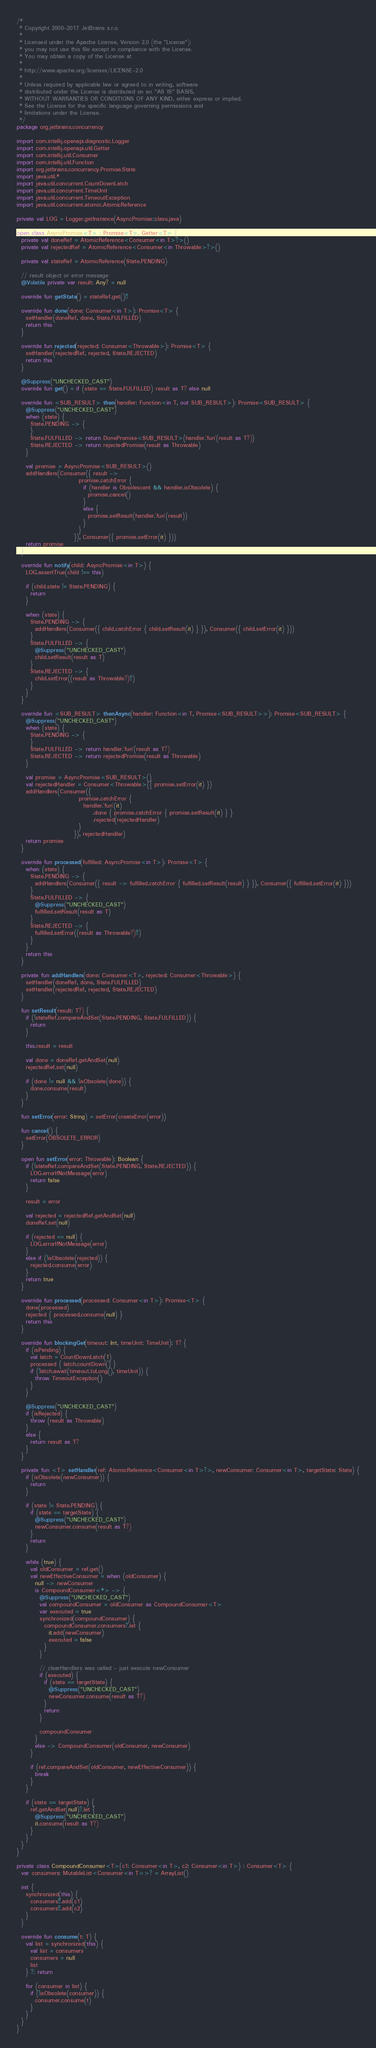Convert code to text. <code><loc_0><loc_0><loc_500><loc_500><_Kotlin_>/*
 * Copyright 2000-2017 JetBrains s.r.o.
 *
 * Licensed under the Apache License, Version 2.0 (the "License");
 * you may not use this file except in compliance with the License.
 * You may obtain a copy of the License at
 *
 * http://www.apache.org/licenses/LICENSE-2.0
 *
 * Unless required by applicable law or agreed to in writing, software
 * distributed under the License is distributed on an "AS IS" BASIS,
 * WITHOUT WARRANTIES OR CONDITIONS OF ANY KIND, either express or implied.
 * See the License for the specific language governing permissions and
 * limitations under the License.
 */
package org.jetbrains.concurrency

import com.intellij.openapi.diagnostic.Logger
import com.intellij.openapi.util.Getter
import com.intellij.util.Consumer
import com.intellij.util.Function
import org.jetbrains.concurrency.Promise.State
import java.util.*
import java.util.concurrent.CountDownLatch
import java.util.concurrent.TimeUnit
import java.util.concurrent.TimeoutException
import java.util.concurrent.atomic.AtomicReference

private val LOG = Logger.getInstance(AsyncPromise::class.java)

open class AsyncPromise<T> : Promise<T>, Getter<T> {
  private val doneRef = AtomicReference<Consumer<in T>?>()
  private val rejectedRef = AtomicReference<Consumer<in Throwable>?>()

  private val stateRef = AtomicReference(State.PENDING)

  // result object or error message
  @Volatile private var result: Any? = null

  override fun getState() = stateRef.get()!!

  override fun done(done: Consumer<in T>): Promise<T> {
    setHandler(doneRef, done, State.FULFILLED)
    return this
  }

  override fun rejected(rejected: Consumer<Throwable>): Promise<T> {
    setHandler(rejectedRef, rejected, State.REJECTED)
    return this
  }

  @Suppress("UNCHECKED_CAST")
  override fun get() = if (state == State.FULFILLED) result as T? else null

  override fun <SUB_RESULT> then(handler: Function<in T, out SUB_RESULT>): Promise<SUB_RESULT> {
    @Suppress("UNCHECKED_CAST")
    when (state) {
      State.PENDING -> {
      }
      State.FULFILLED -> return DonePromise<SUB_RESULT>(handler.`fun`(result as T?))
      State.REJECTED -> return rejectedPromise(result as Throwable)
    }

    val promise = AsyncPromise<SUB_RESULT>()
    addHandlers(Consumer({ result ->
                           promise.catchError {
                             if (handler is Obsolescent && handler.isObsolete) {
                               promise.cancel()
                             }
                             else {
                               promise.setResult(handler.`fun`(result))
                             }
                           }
                         }), Consumer({ promise.setError(it) }))
    return promise
  }

  override fun notify(child: AsyncPromise<in T>) {
    LOG.assertTrue(child !== this)

    if (child.state != State.PENDING) {
      return
    }

    when (state) {
      State.PENDING -> {
        addHandlers(Consumer({ child.catchError { child.setResult(it) } }), Consumer({ child.setError(it) }))
      }
      State.FULFILLED -> {
        @Suppress("UNCHECKED_CAST")
        child.setResult(result as T)
      }
      State.REJECTED -> {
        child.setError((result as Throwable?)!!)
      }
    }
  }

  override fun <SUB_RESULT> thenAsync(handler: Function<in T, Promise<SUB_RESULT>>): Promise<SUB_RESULT> {
    @Suppress("UNCHECKED_CAST")
    when (state) {
      State.PENDING -> {
      }
      State.FULFILLED -> return handler.`fun`(result as T?)
      State.REJECTED -> return rejectedPromise(result as Throwable)
    }

    val promise = AsyncPromise<SUB_RESULT>()
    val rejectedHandler = Consumer<Throwable>({ promise.setError(it) })
    addHandlers(Consumer({
                           promise.catchError {
                             handler.`fun`(it)
                                 .done { promise.catchError { promise.setResult(it) } }
                                 .rejected(rejectedHandler)
                           }
                         }), rejectedHandler)
    return promise
  }

  override fun processed(fulfilled: AsyncPromise<in T>): Promise<T> {
    when (state) {
      State.PENDING -> {
        addHandlers(Consumer({ result -> fulfilled.catchError { fulfilled.setResult(result) } }), Consumer({ fulfilled.setError(it) }))
      }
      State.FULFILLED -> {
        @Suppress("UNCHECKED_CAST")
        fulfilled.setResult(result as T)
      }
      State.REJECTED -> {
        fulfilled.setError((result as Throwable?)!!)
      }
    }
    return this
  }

  private fun addHandlers(done: Consumer<T>, rejected: Consumer<Throwable>) {
    setHandler(doneRef, done, State.FULFILLED)
    setHandler(rejectedRef, rejected, State.REJECTED)
  }

  fun setResult(result: T?) {
    if (!stateRef.compareAndSet(State.PENDING, State.FULFILLED)) {
      return
    }

    this.result = result

    val done = doneRef.getAndSet(null)
    rejectedRef.set(null)

    if (done != null && !isObsolete(done)) {
      done.consume(result)
    }
  }

  fun setError(error: String) = setError(createError(error))

  fun cancel() {
    setError(OBSOLETE_ERROR)
  }

  open fun setError(error: Throwable): Boolean {
    if (!stateRef.compareAndSet(State.PENDING, State.REJECTED)) {
      LOG.errorIfNotMessage(error)
      return false
    }

    result = error

    val rejected = rejectedRef.getAndSet(null)
    doneRef.set(null)

    if (rejected == null) {
      LOG.errorIfNotMessage(error)
    }
    else if (!isObsolete(rejected)) {
      rejected.consume(error)
    }
    return true
  }

  override fun processed(processed: Consumer<in T>): Promise<T> {
    done(processed)
    rejected { processed.consume(null) }
    return this
  }

  override fun blockingGet(timeout: Int, timeUnit: TimeUnit): T? {
    if (isPending) {
      val latch = CountDownLatch(1)
      processed { latch.countDown() }
      if (!latch.await(timeout.toLong(), timeUnit)) {
        throw TimeoutException()
      }
    }

    @Suppress("UNCHECKED_CAST")
    if (isRejected) {
      throw (result as Throwable)
    }
    else {
      return result as T?
    }
  }

  private fun <T> setHandler(ref: AtomicReference<Consumer<in T>?>, newConsumer: Consumer<in T>, targetState: State) {
    if (isObsolete(newConsumer)) {
      return
    }

    if (state != State.PENDING) {
      if (state == targetState) {
        @Suppress("UNCHECKED_CAST")
        newConsumer.consume(result as T?)
      }
      return
    }

    while (true) {
      val oldConsumer = ref.get()
      val newEffectiveConsumer = when (oldConsumer) {
        null -> newConsumer
        is CompoundConsumer<*> -> {
          @Suppress("UNCHECKED_CAST")
          val compoundConsumer = oldConsumer as CompoundConsumer<T>
          var executed = true
          synchronized(compoundConsumer) {
            compoundConsumer.consumers?.let {
              it.add(newConsumer)
              executed = false
            }
          }

          // clearHandlers was called - just execute newConsumer
          if (executed) {
            if (state == targetState) {
              @Suppress("UNCHECKED_CAST")
              newConsumer.consume(result as T?)
            }
            return
          }

          compoundConsumer
        }
        else -> CompoundConsumer(oldConsumer, newConsumer)
      }

      if (ref.compareAndSet(oldConsumer, newEffectiveConsumer)) {
        break
      }
    }

    if (state == targetState) {
      ref.getAndSet(null)?.let {
        @Suppress("UNCHECKED_CAST")
        it.consume(result as T?)
      }
    }
  }
}

private class CompoundConsumer<T>(c1: Consumer<in T>, c2: Consumer<in T>) : Consumer<T> {
  var consumers: MutableList<Consumer<in T>>? = ArrayList()

  init {
    synchronized(this) {
      consumers!!.add(c1)
      consumers!!.add(c2)
    }
  }

  override fun consume(t: T) {
    val list = synchronized(this) {
      val list = consumers
      consumers = null
      list
    } ?: return

    for (consumer in list) {
      if (!isObsolete(consumer)) {
        consumer.consume(t)
      }
    }
  }
}
</code> 